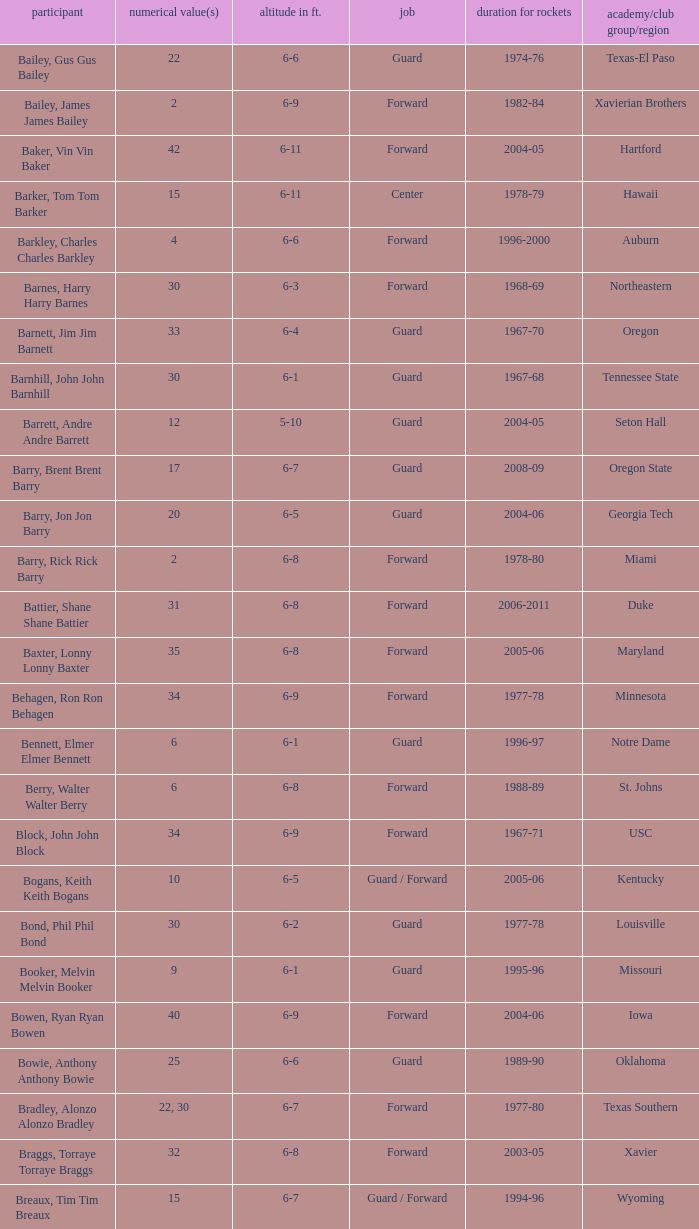What school did the forward whose number is 10 belong to? Arizona. I'm looking to parse the entire table for insights. Could you assist me with that? {'header': ['participant', 'numerical value(s)', 'altitude in ft.', 'job', 'duration for rockets', 'academy/club group/region'], 'rows': [['Bailey, Gus Gus Bailey', '22', '6-6', 'Guard', '1974-76', 'Texas-El Paso'], ['Bailey, James James Bailey', '2', '6-9', 'Forward', '1982-84', 'Xavierian Brothers'], ['Baker, Vin Vin Baker', '42', '6-11', 'Forward', '2004-05', 'Hartford'], ['Barker, Tom Tom Barker', '15', '6-11', 'Center', '1978-79', 'Hawaii'], ['Barkley, Charles Charles Barkley', '4', '6-6', 'Forward', '1996-2000', 'Auburn'], ['Barnes, Harry Harry Barnes', '30', '6-3', 'Forward', '1968-69', 'Northeastern'], ['Barnett, Jim Jim Barnett', '33', '6-4', 'Guard', '1967-70', 'Oregon'], ['Barnhill, John John Barnhill', '30', '6-1', 'Guard', '1967-68', 'Tennessee State'], ['Barrett, Andre Andre Barrett', '12', '5-10', 'Guard', '2004-05', 'Seton Hall'], ['Barry, Brent Brent Barry', '17', '6-7', 'Guard', '2008-09', 'Oregon State'], ['Barry, Jon Jon Barry', '20', '6-5', 'Guard', '2004-06', 'Georgia Tech'], ['Barry, Rick Rick Barry', '2', '6-8', 'Forward', '1978-80', 'Miami'], ['Battier, Shane Shane Battier', '31', '6-8', 'Forward', '2006-2011', 'Duke'], ['Baxter, Lonny Lonny Baxter', '35', '6-8', 'Forward', '2005-06', 'Maryland'], ['Behagen, Ron Ron Behagen', '34', '6-9', 'Forward', '1977-78', 'Minnesota'], ['Bennett, Elmer Elmer Bennett', '6', '6-1', 'Guard', '1996-97', 'Notre Dame'], ['Berry, Walter Walter Berry', '6', '6-8', 'Forward', '1988-89', 'St. Johns'], ['Block, John John Block', '34', '6-9', 'Forward', '1967-71', 'USC'], ['Bogans, Keith Keith Bogans', '10', '6-5', 'Guard / Forward', '2005-06', 'Kentucky'], ['Bond, Phil Phil Bond', '30', '6-2', 'Guard', '1977-78', 'Louisville'], ['Booker, Melvin Melvin Booker', '9', '6-1', 'Guard', '1995-96', 'Missouri'], ['Bowen, Ryan Ryan Bowen', '40', '6-9', 'Forward', '2004-06', 'Iowa'], ['Bowie, Anthony Anthony Bowie', '25', '6-6', 'Guard', '1989-90', 'Oklahoma'], ['Bradley, Alonzo Alonzo Bradley', '22, 30', '6-7', 'Forward', '1977-80', 'Texas Southern'], ['Braggs, Torraye Torraye Braggs', '32', '6-8', 'Forward', '2003-05', 'Xavier'], ['Breaux, Tim Tim Breaux', '15', '6-7', 'Guard / Forward', '1994-96', 'Wyoming'], ['Britt, Tyrone Tyrone Britt', '31', '6-4', 'Guard', '1967-68', 'Johnson C. Smith'], ['Brooks, Aaron Aaron Brooks', '0', '6-0', 'Guard', '2007-2011, 2013', 'Oregon'], ['Brooks, Scott Scott Brooks', '1', '5-11', 'Guard', '1992-95', 'UC-Irvine'], ['Brown, Chucky Chucky Brown', '52', '6-8', 'Forward', '1994-96', 'North Carolina'], ['Brown, Tony Tony Brown', '35', '6-6', 'Forward', '1988-89', 'Arkansas'], ['Brown, Tierre Tierre Brown', '10', '6-2', 'Guard', '2001-02', 'McNesse State'], ['Brunson, Rick Rick Brunson', '9', '6-4', 'Guard', '2005-06', 'Temple'], ['Bryant, Joe Joe Bryant', '22', '6-9', 'Forward / Guard', '1982-83', 'LaSalle'], ['Bryant, Mark Mark Bryant', '2', '6-9', 'Forward', '1995-96', 'Seton Hall'], ['Budinger, Chase Chase Budinger', '10', '6-7', 'Forward', '2009-2012', 'Arizona'], ['Bullard, Matt Matt Bullard', '50', '6-10', 'Forward', '1990-94, 1996-2001', 'Iowa']]} 